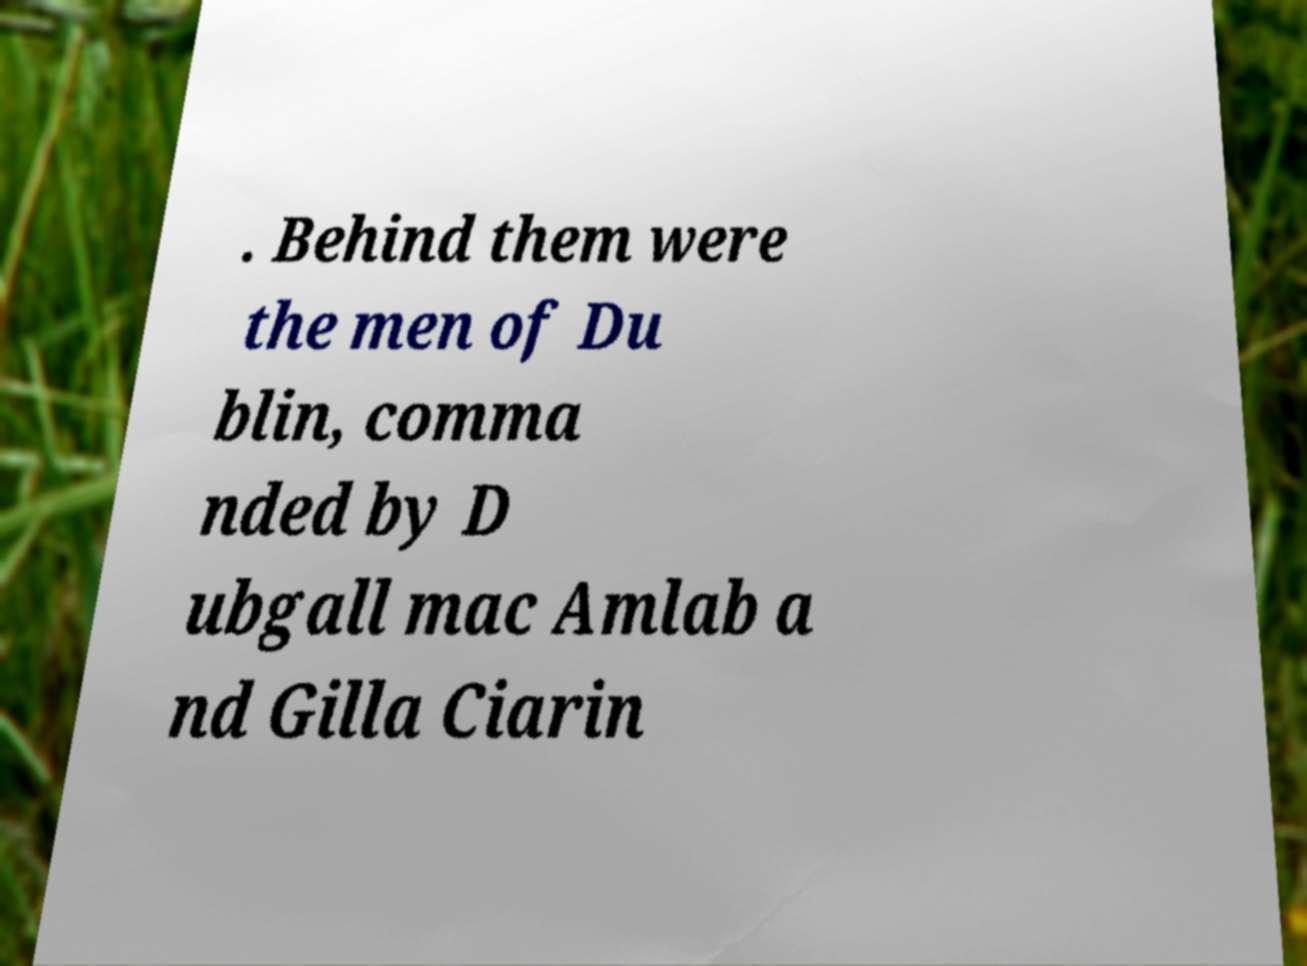Please read and relay the text visible in this image. What does it say? . Behind them were the men of Du blin, comma nded by D ubgall mac Amlab a nd Gilla Ciarin 